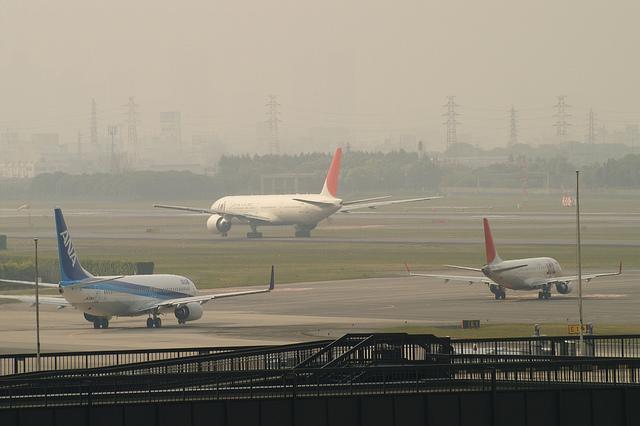How many planes are on the airport?
Give a very brief answer. 3. How many airplanes are there?
Give a very brief answer. 3. How many cats with green eyes are there?
Give a very brief answer. 0. 